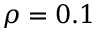<formula> <loc_0><loc_0><loc_500><loc_500>\rho = 0 . 1</formula> 